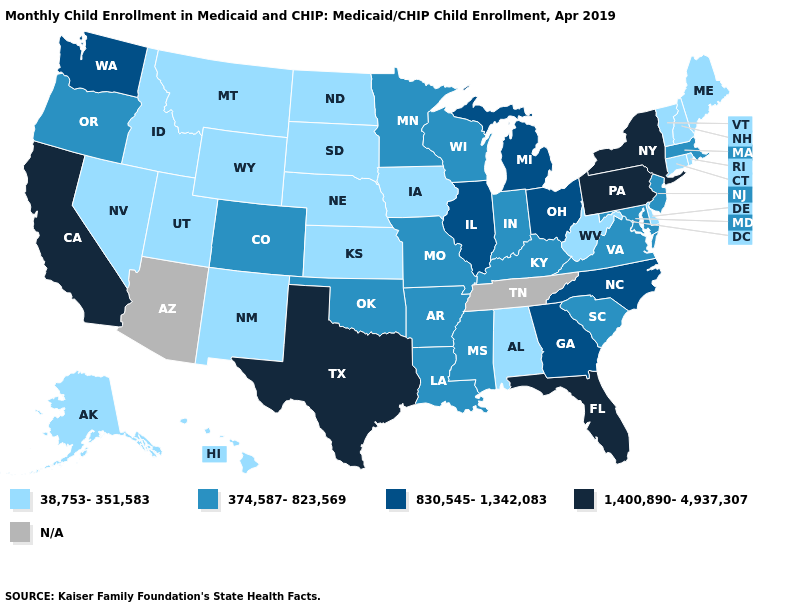Does North Dakota have the lowest value in the MidWest?
Give a very brief answer. Yes. What is the value of Pennsylvania?
Answer briefly. 1,400,890-4,937,307. How many symbols are there in the legend?
Concise answer only. 5. Among the states that border North Carolina , does Georgia have the highest value?
Write a very short answer. Yes. Name the states that have a value in the range 374,587-823,569?
Quick response, please. Arkansas, Colorado, Indiana, Kentucky, Louisiana, Maryland, Massachusetts, Minnesota, Mississippi, Missouri, New Jersey, Oklahoma, Oregon, South Carolina, Virginia, Wisconsin. What is the lowest value in the West?
Give a very brief answer. 38,753-351,583. Does Ohio have the lowest value in the USA?
Answer briefly. No. Name the states that have a value in the range 830,545-1,342,083?
Keep it brief. Georgia, Illinois, Michigan, North Carolina, Ohio, Washington. Name the states that have a value in the range 1,400,890-4,937,307?
Answer briefly. California, Florida, New York, Pennsylvania, Texas. What is the lowest value in the South?
Write a very short answer. 38,753-351,583. What is the highest value in the MidWest ?
Give a very brief answer. 830,545-1,342,083. What is the value of Maine?
Be succinct. 38,753-351,583. What is the value of New Mexico?
Quick response, please. 38,753-351,583. Does the first symbol in the legend represent the smallest category?
Quick response, please. Yes. 